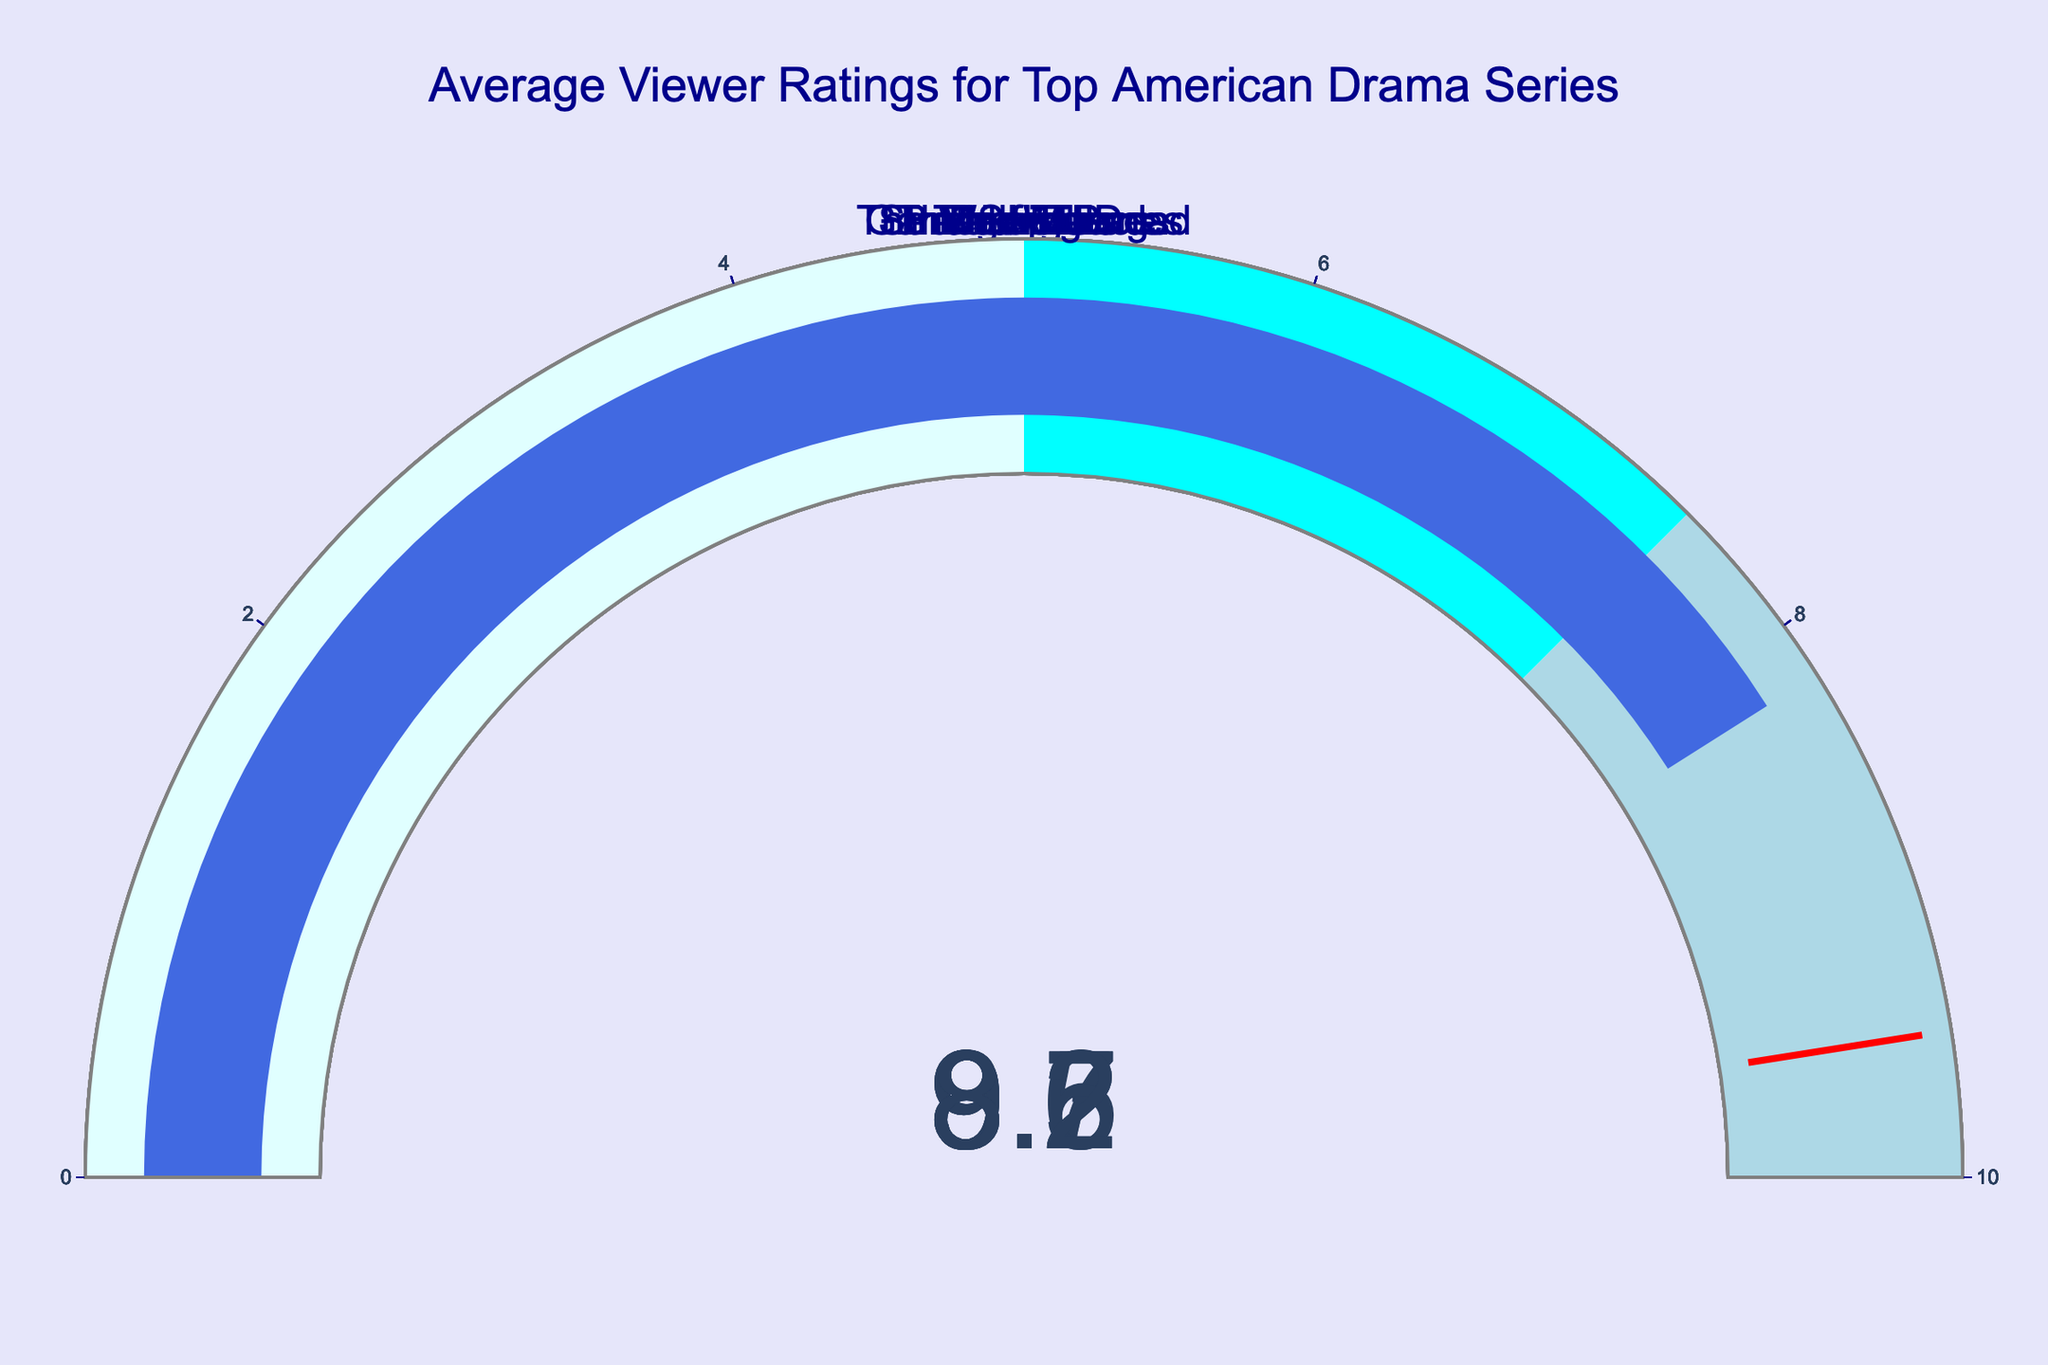What is the highest average viewer rating among the series? To find the highest rating, visually scan the gauges for the highest number. Breaking Bad has the highest rating with 9.5.
Answer: 9.5 How many series have an average viewer rating of 8.7? Check the gauges for occurrences of the rating 8.7. Mad Men and Stranger Things have this rating.
Answer: 2 Which series has the lowest average viewer rating? Identify the series with the smallest rating on the gauges. The Walking Dead has the lowest rating, which is 8.2.
Answer: The Walking Dead What is the range of the average viewer ratings? Subtract the lowest rating from the highest rating. The range is 9.5 - 8.2 = 1.3.
Answer: 1.3 Of the series with ratings above 9, which one has the lowest rating? Among series with ratings above 9, identify the smallest rating. Game of Thrones and The Sopranos are at 9.2, but The Wire is at 9.3, and none is lower. Therefore, 9.2 is the lowest.
Answer: 9.2 Are there any series with the same average viewer rating? Check the gauges to see if any ratings are repeated. Game of Thrones and The Sopranos both have a rating of 9.2. Mad Men and Stranger Things both have a rating of 8.7.
Answer: Yes What's the median average viewer rating of the series? Arrange the series ratings in ascending order and find the middle value. The ordered ratings are 8.2, 8.6, 8.7, 8.7, 9.2, 9.2, 9.3, 9.5. The middle values are 8.7 and 9.2, so the median is (8.7 + 9.2) / 2 = 8.95.
Answer: 8.95 What is the average viewer rating of the top three-rated series? Calculate the mean of the ratings for Breaking Bad (9.5), The Wire (9.3), and Game of Thrones (9.2). The sum is 9.5 + 9.3 + 9.2 = 28. The average is 28 / 3 = 9.33.
Answer: 9.33 